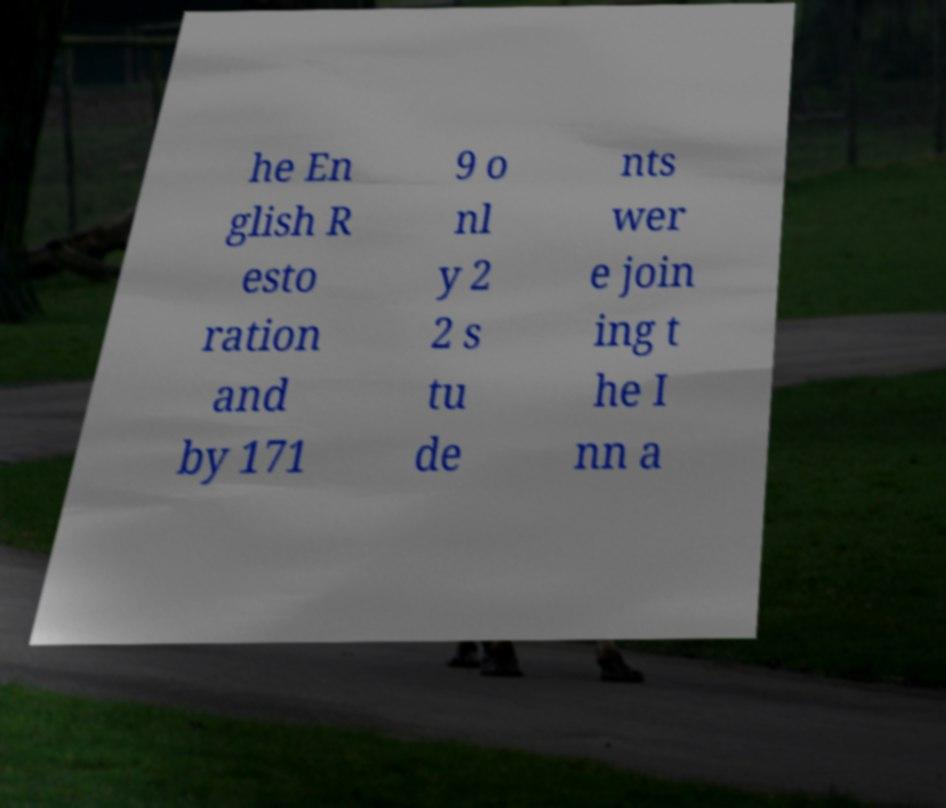Could you extract and type out the text from this image? he En glish R esto ration and by 171 9 o nl y 2 2 s tu de nts wer e join ing t he I nn a 